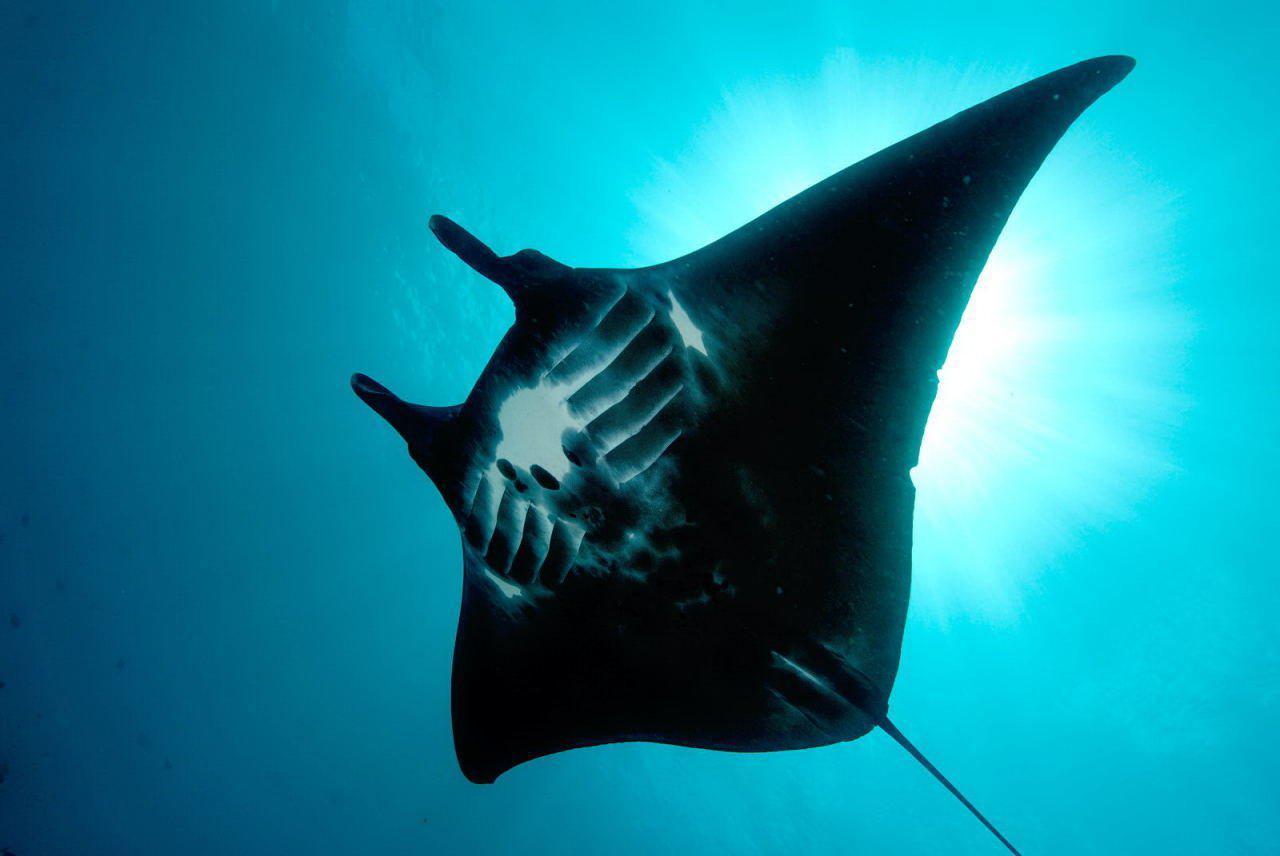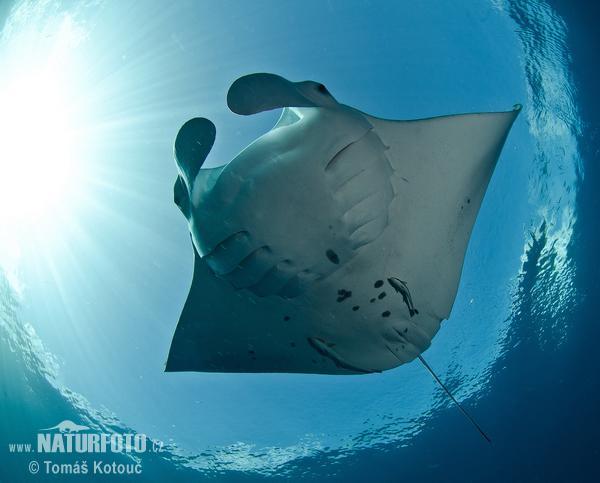The first image is the image on the left, the second image is the image on the right. For the images displayed, is the sentence "An image shows one mostly black stingray swimming toward the upper left." factually correct? Answer yes or no. Yes. The first image is the image on the left, the second image is the image on the right. Assess this claim about the two images: "The stingray on the left is black.". Correct or not? Answer yes or no. Yes. 